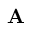<formula> <loc_0><loc_0><loc_500><loc_500>{ A }</formula> 